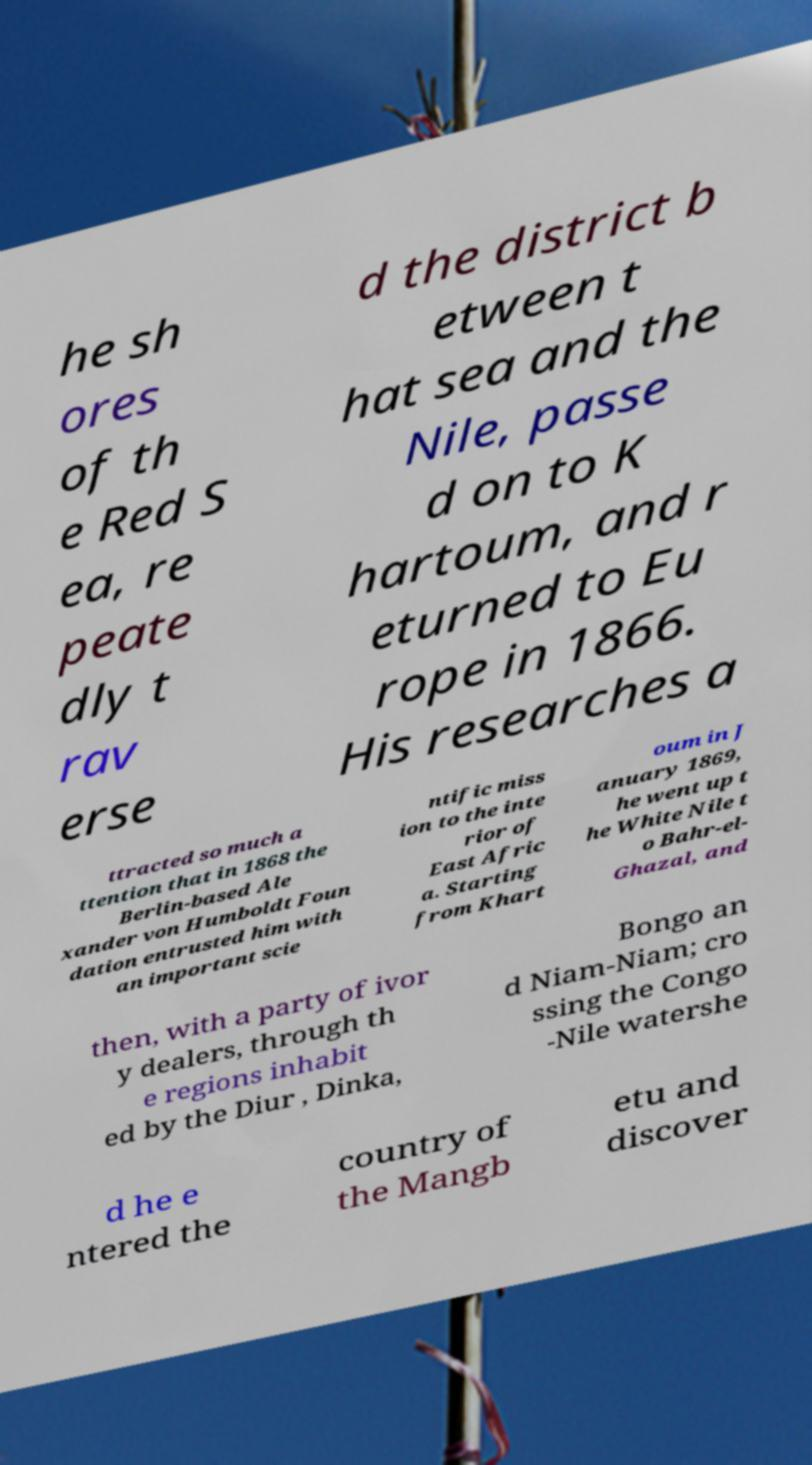There's text embedded in this image that I need extracted. Can you transcribe it verbatim? he sh ores of th e Red S ea, re peate dly t rav erse d the district b etween t hat sea and the Nile, passe d on to K hartoum, and r eturned to Eu rope in 1866. His researches a ttracted so much a ttention that in 1868 the Berlin-based Ale xander von Humboldt Foun dation entrusted him with an important scie ntific miss ion to the inte rior of East Afric a. Starting from Khart oum in J anuary 1869, he went up t he White Nile t o Bahr-el- Ghazal, and then, with a party of ivor y dealers, through th e regions inhabit ed by the Diur , Dinka, Bongo an d Niam-Niam; cro ssing the Congo -Nile watershe d he e ntered the country of the Mangb etu and discover 